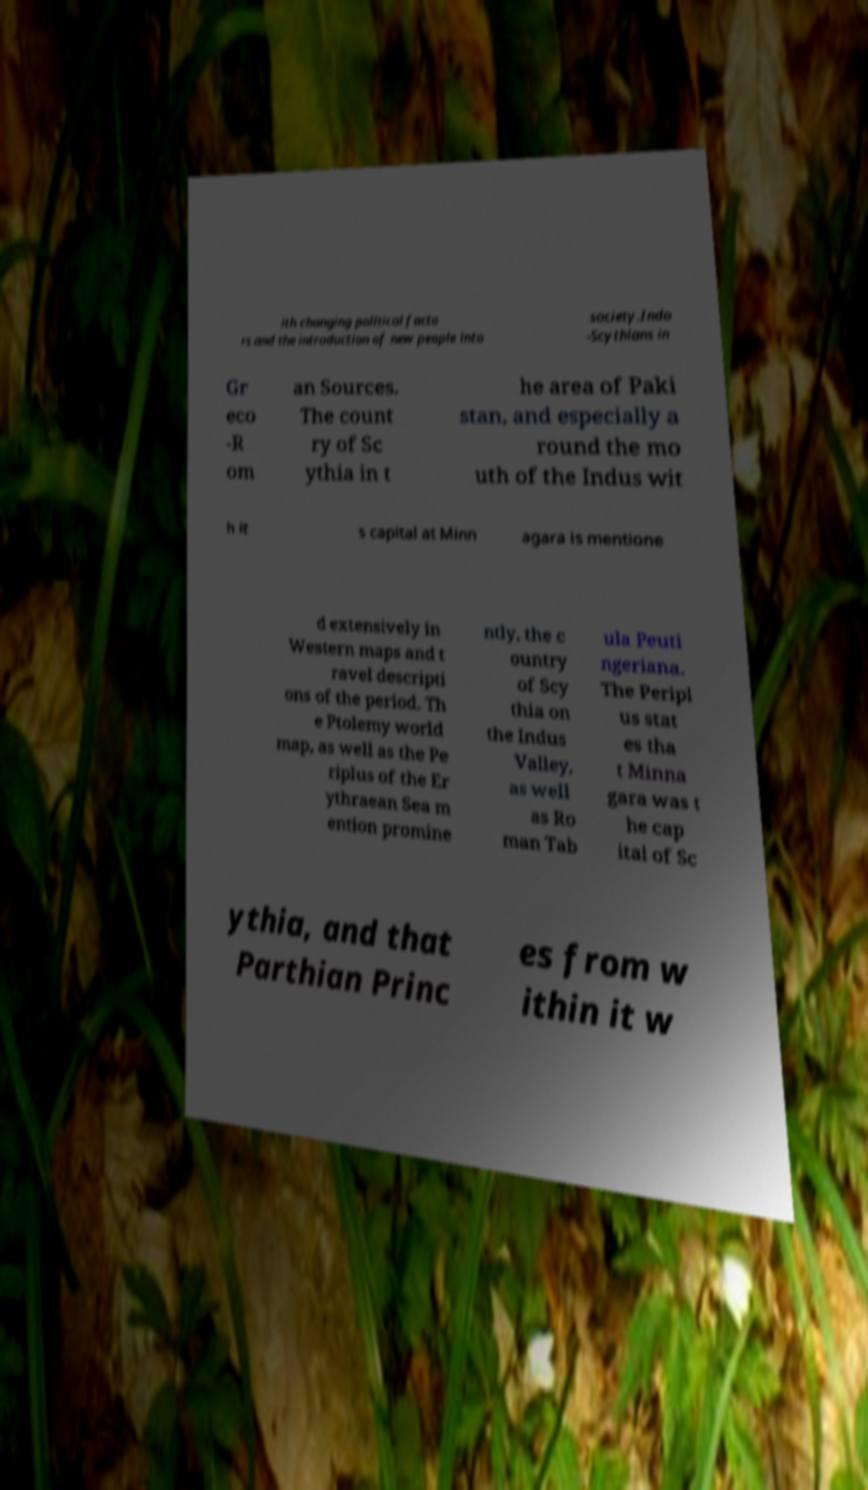There's text embedded in this image that I need extracted. Can you transcribe it verbatim? ith changing political facto rs and the introduction of new people into society.Indo -Scythians in Gr eco -R om an Sources. The count ry of Sc ythia in t he area of Paki stan, and especially a round the mo uth of the Indus wit h it s capital at Minn agara is mentione d extensively in Western maps and t ravel descripti ons of the period. Th e Ptolemy world map, as well as the Pe riplus of the Er ythraean Sea m ention promine ntly, the c ountry of Scy thia on the Indus Valley, as well as Ro man Tab ula Peuti ngeriana. The Peripl us stat es tha t Minna gara was t he cap ital of Sc ythia, and that Parthian Princ es from w ithin it w 